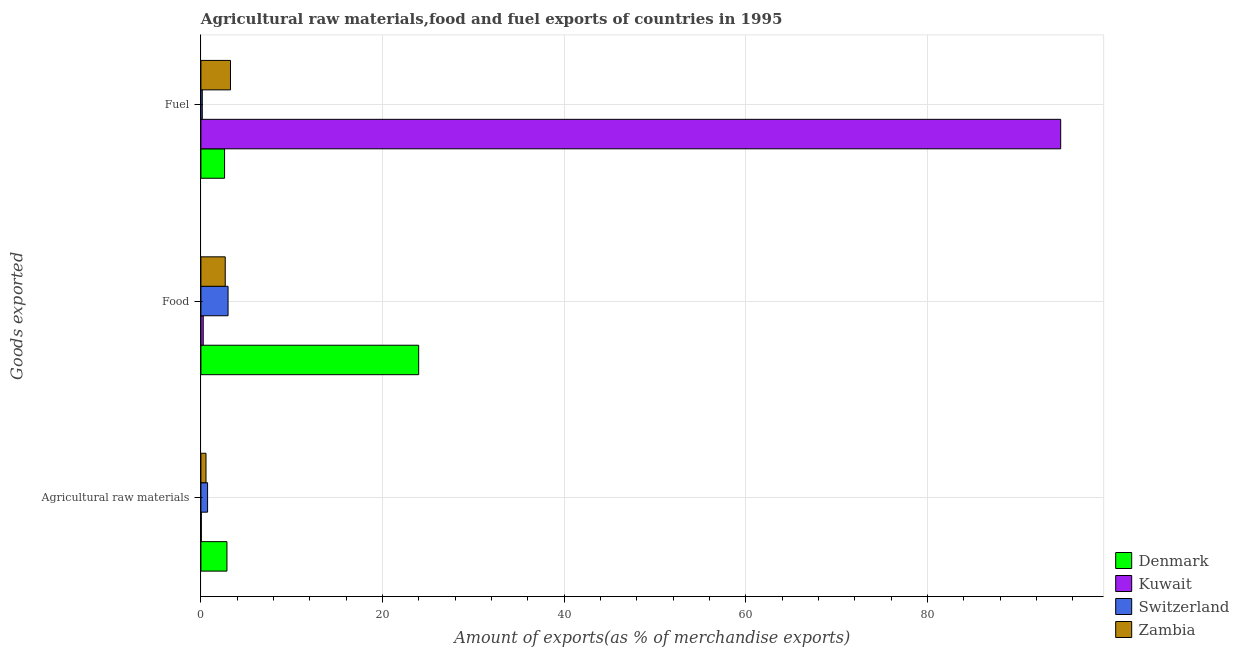How many different coloured bars are there?
Your response must be concise. 4. How many groups of bars are there?
Provide a succinct answer. 3. Are the number of bars on each tick of the Y-axis equal?
Keep it short and to the point. Yes. How many bars are there on the 3rd tick from the bottom?
Make the answer very short. 4. What is the label of the 1st group of bars from the top?
Offer a terse response. Fuel. What is the percentage of food exports in Kuwait?
Keep it short and to the point. 0.26. Across all countries, what is the maximum percentage of raw materials exports?
Make the answer very short. 2.87. Across all countries, what is the minimum percentage of raw materials exports?
Provide a succinct answer. 0.04. In which country was the percentage of fuel exports maximum?
Offer a very short reply. Kuwait. In which country was the percentage of food exports minimum?
Give a very brief answer. Kuwait. What is the total percentage of food exports in the graph?
Your answer should be very brief. 29.9. What is the difference between the percentage of fuel exports in Switzerland and that in Zambia?
Provide a succinct answer. -3.11. What is the difference between the percentage of food exports in Switzerland and the percentage of fuel exports in Kuwait?
Provide a short and direct response. -91.69. What is the average percentage of raw materials exports per country?
Ensure brevity in your answer.  1.05. What is the difference between the percentage of food exports and percentage of fuel exports in Zambia?
Your response must be concise. -0.58. What is the ratio of the percentage of fuel exports in Denmark to that in Kuwait?
Keep it short and to the point. 0.03. Is the difference between the percentage of food exports in Zambia and Kuwait greater than the difference between the percentage of fuel exports in Zambia and Kuwait?
Provide a short and direct response. Yes. What is the difference between the highest and the second highest percentage of fuel exports?
Offer a very short reply. 91.42. What is the difference between the highest and the lowest percentage of fuel exports?
Make the answer very short. 94.53. In how many countries, is the percentage of fuel exports greater than the average percentage of fuel exports taken over all countries?
Your answer should be very brief. 1. Is the sum of the percentage of fuel exports in Kuwait and Switzerland greater than the maximum percentage of food exports across all countries?
Ensure brevity in your answer.  Yes. What does the 4th bar from the top in Agricultural raw materials represents?
Your answer should be compact. Denmark. How many bars are there?
Give a very brief answer. 12. Are all the bars in the graph horizontal?
Offer a terse response. Yes. What is the difference between two consecutive major ticks on the X-axis?
Your response must be concise. 20. Does the graph contain any zero values?
Your answer should be very brief. No. Does the graph contain grids?
Offer a terse response. Yes. What is the title of the graph?
Make the answer very short. Agricultural raw materials,food and fuel exports of countries in 1995. Does "St. Lucia" appear as one of the legend labels in the graph?
Make the answer very short. No. What is the label or title of the X-axis?
Your answer should be very brief. Amount of exports(as % of merchandise exports). What is the label or title of the Y-axis?
Give a very brief answer. Goods exported. What is the Amount of exports(as % of merchandise exports) of Denmark in Agricultural raw materials?
Keep it short and to the point. 2.87. What is the Amount of exports(as % of merchandise exports) of Kuwait in Agricultural raw materials?
Give a very brief answer. 0.04. What is the Amount of exports(as % of merchandise exports) of Switzerland in Agricultural raw materials?
Your answer should be very brief. 0.73. What is the Amount of exports(as % of merchandise exports) of Zambia in Agricultural raw materials?
Give a very brief answer. 0.56. What is the Amount of exports(as % of merchandise exports) in Denmark in Food?
Offer a very short reply. 23.98. What is the Amount of exports(as % of merchandise exports) of Kuwait in Food?
Your answer should be very brief. 0.26. What is the Amount of exports(as % of merchandise exports) in Switzerland in Food?
Your response must be concise. 2.99. What is the Amount of exports(as % of merchandise exports) of Zambia in Food?
Your response must be concise. 2.68. What is the Amount of exports(as % of merchandise exports) in Denmark in Fuel?
Your response must be concise. 2.6. What is the Amount of exports(as % of merchandise exports) in Kuwait in Fuel?
Give a very brief answer. 94.68. What is the Amount of exports(as % of merchandise exports) in Switzerland in Fuel?
Offer a terse response. 0.15. What is the Amount of exports(as % of merchandise exports) in Zambia in Fuel?
Provide a short and direct response. 3.26. Across all Goods exported, what is the maximum Amount of exports(as % of merchandise exports) of Denmark?
Offer a very short reply. 23.98. Across all Goods exported, what is the maximum Amount of exports(as % of merchandise exports) of Kuwait?
Make the answer very short. 94.68. Across all Goods exported, what is the maximum Amount of exports(as % of merchandise exports) of Switzerland?
Make the answer very short. 2.99. Across all Goods exported, what is the maximum Amount of exports(as % of merchandise exports) of Zambia?
Ensure brevity in your answer.  3.26. Across all Goods exported, what is the minimum Amount of exports(as % of merchandise exports) of Denmark?
Your answer should be very brief. 2.6. Across all Goods exported, what is the minimum Amount of exports(as % of merchandise exports) in Kuwait?
Offer a very short reply. 0.04. Across all Goods exported, what is the minimum Amount of exports(as % of merchandise exports) of Switzerland?
Provide a succinct answer. 0.15. Across all Goods exported, what is the minimum Amount of exports(as % of merchandise exports) of Zambia?
Your response must be concise. 0.56. What is the total Amount of exports(as % of merchandise exports) of Denmark in the graph?
Give a very brief answer. 29.45. What is the total Amount of exports(as % of merchandise exports) in Kuwait in the graph?
Offer a terse response. 94.98. What is the total Amount of exports(as % of merchandise exports) in Switzerland in the graph?
Your answer should be compact. 3.87. What is the total Amount of exports(as % of merchandise exports) in Zambia in the graph?
Give a very brief answer. 6.5. What is the difference between the Amount of exports(as % of merchandise exports) of Denmark in Agricultural raw materials and that in Food?
Provide a succinct answer. -21.11. What is the difference between the Amount of exports(as % of merchandise exports) in Kuwait in Agricultural raw materials and that in Food?
Provide a succinct answer. -0.21. What is the difference between the Amount of exports(as % of merchandise exports) of Switzerland in Agricultural raw materials and that in Food?
Offer a very short reply. -2.25. What is the difference between the Amount of exports(as % of merchandise exports) of Zambia in Agricultural raw materials and that in Food?
Make the answer very short. -2.12. What is the difference between the Amount of exports(as % of merchandise exports) in Denmark in Agricultural raw materials and that in Fuel?
Make the answer very short. 0.26. What is the difference between the Amount of exports(as % of merchandise exports) in Kuwait in Agricultural raw materials and that in Fuel?
Make the answer very short. -94.63. What is the difference between the Amount of exports(as % of merchandise exports) of Switzerland in Agricultural raw materials and that in Fuel?
Your answer should be compact. 0.58. What is the difference between the Amount of exports(as % of merchandise exports) in Zambia in Agricultural raw materials and that in Fuel?
Keep it short and to the point. -2.7. What is the difference between the Amount of exports(as % of merchandise exports) in Denmark in Food and that in Fuel?
Provide a short and direct response. 21.37. What is the difference between the Amount of exports(as % of merchandise exports) in Kuwait in Food and that in Fuel?
Ensure brevity in your answer.  -94.42. What is the difference between the Amount of exports(as % of merchandise exports) in Switzerland in Food and that in Fuel?
Offer a very short reply. 2.84. What is the difference between the Amount of exports(as % of merchandise exports) of Zambia in Food and that in Fuel?
Keep it short and to the point. -0.58. What is the difference between the Amount of exports(as % of merchandise exports) in Denmark in Agricultural raw materials and the Amount of exports(as % of merchandise exports) in Kuwait in Food?
Give a very brief answer. 2.61. What is the difference between the Amount of exports(as % of merchandise exports) in Denmark in Agricultural raw materials and the Amount of exports(as % of merchandise exports) in Switzerland in Food?
Your answer should be very brief. -0.12. What is the difference between the Amount of exports(as % of merchandise exports) in Denmark in Agricultural raw materials and the Amount of exports(as % of merchandise exports) in Zambia in Food?
Ensure brevity in your answer.  0.19. What is the difference between the Amount of exports(as % of merchandise exports) in Kuwait in Agricultural raw materials and the Amount of exports(as % of merchandise exports) in Switzerland in Food?
Provide a short and direct response. -2.94. What is the difference between the Amount of exports(as % of merchandise exports) in Kuwait in Agricultural raw materials and the Amount of exports(as % of merchandise exports) in Zambia in Food?
Offer a terse response. -2.63. What is the difference between the Amount of exports(as % of merchandise exports) of Switzerland in Agricultural raw materials and the Amount of exports(as % of merchandise exports) of Zambia in Food?
Make the answer very short. -1.94. What is the difference between the Amount of exports(as % of merchandise exports) of Denmark in Agricultural raw materials and the Amount of exports(as % of merchandise exports) of Kuwait in Fuel?
Your response must be concise. -91.81. What is the difference between the Amount of exports(as % of merchandise exports) of Denmark in Agricultural raw materials and the Amount of exports(as % of merchandise exports) of Switzerland in Fuel?
Provide a short and direct response. 2.72. What is the difference between the Amount of exports(as % of merchandise exports) of Denmark in Agricultural raw materials and the Amount of exports(as % of merchandise exports) of Zambia in Fuel?
Your answer should be very brief. -0.39. What is the difference between the Amount of exports(as % of merchandise exports) in Kuwait in Agricultural raw materials and the Amount of exports(as % of merchandise exports) in Switzerland in Fuel?
Offer a terse response. -0.11. What is the difference between the Amount of exports(as % of merchandise exports) of Kuwait in Agricultural raw materials and the Amount of exports(as % of merchandise exports) of Zambia in Fuel?
Make the answer very short. -3.21. What is the difference between the Amount of exports(as % of merchandise exports) of Switzerland in Agricultural raw materials and the Amount of exports(as % of merchandise exports) of Zambia in Fuel?
Provide a short and direct response. -2.52. What is the difference between the Amount of exports(as % of merchandise exports) in Denmark in Food and the Amount of exports(as % of merchandise exports) in Kuwait in Fuel?
Your answer should be compact. -70.7. What is the difference between the Amount of exports(as % of merchandise exports) of Denmark in Food and the Amount of exports(as % of merchandise exports) of Switzerland in Fuel?
Provide a succinct answer. 23.83. What is the difference between the Amount of exports(as % of merchandise exports) in Denmark in Food and the Amount of exports(as % of merchandise exports) in Zambia in Fuel?
Ensure brevity in your answer.  20.72. What is the difference between the Amount of exports(as % of merchandise exports) in Kuwait in Food and the Amount of exports(as % of merchandise exports) in Switzerland in Fuel?
Give a very brief answer. 0.1. What is the difference between the Amount of exports(as % of merchandise exports) in Kuwait in Food and the Amount of exports(as % of merchandise exports) in Zambia in Fuel?
Offer a very short reply. -3. What is the difference between the Amount of exports(as % of merchandise exports) of Switzerland in Food and the Amount of exports(as % of merchandise exports) of Zambia in Fuel?
Offer a terse response. -0.27. What is the average Amount of exports(as % of merchandise exports) of Denmark per Goods exported?
Provide a succinct answer. 9.82. What is the average Amount of exports(as % of merchandise exports) of Kuwait per Goods exported?
Give a very brief answer. 31.66. What is the average Amount of exports(as % of merchandise exports) in Switzerland per Goods exported?
Your response must be concise. 1.29. What is the average Amount of exports(as % of merchandise exports) of Zambia per Goods exported?
Keep it short and to the point. 2.17. What is the difference between the Amount of exports(as % of merchandise exports) of Denmark and Amount of exports(as % of merchandise exports) of Kuwait in Agricultural raw materials?
Provide a succinct answer. 2.82. What is the difference between the Amount of exports(as % of merchandise exports) in Denmark and Amount of exports(as % of merchandise exports) in Switzerland in Agricultural raw materials?
Ensure brevity in your answer.  2.13. What is the difference between the Amount of exports(as % of merchandise exports) of Denmark and Amount of exports(as % of merchandise exports) of Zambia in Agricultural raw materials?
Your response must be concise. 2.31. What is the difference between the Amount of exports(as % of merchandise exports) of Kuwait and Amount of exports(as % of merchandise exports) of Switzerland in Agricultural raw materials?
Your answer should be very brief. -0.69. What is the difference between the Amount of exports(as % of merchandise exports) of Kuwait and Amount of exports(as % of merchandise exports) of Zambia in Agricultural raw materials?
Give a very brief answer. -0.52. What is the difference between the Amount of exports(as % of merchandise exports) of Switzerland and Amount of exports(as % of merchandise exports) of Zambia in Agricultural raw materials?
Your answer should be very brief. 0.17. What is the difference between the Amount of exports(as % of merchandise exports) of Denmark and Amount of exports(as % of merchandise exports) of Kuwait in Food?
Your answer should be compact. 23.72. What is the difference between the Amount of exports(as % of merchandise exports) of Denmark and Amount of exports(as % of merchandise exports) of Switzerland in Food?
Your answer should be very brief. 20.99. What is the difference between the Amount of exports(as % of merchandise exports) of Denmark and Amount of exports(as % of merchandise exports) of Zambia in Food?
Your answer should be very brief. 21.3. What is the difference between the Amount of exports(as % of merchandise exports) in Kuwait and Amount of exports(as % of merchandise exports) in Switzerland in Food?
Give a very brief answer. -2.73. What is the difference between the Amount of exports(as % of merchandise exports) in Kuwait and Amount of exports(as % of merchandise exports) in Zambia in Food?
Offer a very short reply. -2.42. What is the difference between the Amount of exports(as % of merchandise exports) of Switzerland and Amount of exports(as % of merchandise exports) of Zambia in Food?
Your answer should be very brief. 0.31. What is the difference between the Amount of exports(as % of merchandise exports) of Denmark and Amount of exports(as % of merchandise exports) of Kuwait in Fuel?
Your response must be concise. -92.07. What is the difference between the Amount of exports(as % of merchandise exports) of Denmark and Amount of exports(as % of merchandise exports) of Switzerland in Fuel?
Ensure brevity in your answer.  2.45. What is the difference between the Amount of exports(as % of merchandise exports) of Denmark and Amount of exports(as % of merchandise exports) of Zambia in Fuel?
Make the answer very short. -0.65. What is the difference between the Amount of exports(as % of merchandise exports) of Kuwait and Amount of exports(as % of merchandise exports) of Switzerland in Fuel?
Make the answer very short. 94.53. What is the difference between the Amount of exports(as % of merchandise exports) of Kuwait and Amount of exports(as % of merchandise exports) of Zambia in Fuel?
Offer a very short reply. 91.42. What is the difference between the Amount of exports(as % of merchandise exports) of Switzerland and Amount of exports(as % of merchandise exports) of Zambia in Fuel?
Give a very brief answer. -3.11. What is the ratio of the Amount of exports(as % of merchandise exports) in Denmark in Agricultural raw materials to that in Food?
Give a very brief answer. 0.12. What is the ratio of the Amount of exports(as % of merchandise exports) of Kuwait in Agricultural raw materials to that in Food?
Your answer should be very brief. 0.17. What is the ratio of the Amount of exports(as % of merchandise exports) in Switzerland in Agricultural raw materials to that in Food?
Offer a very short reply. 0.25. What is the ratio of the Amount of exports(as % of merchandise exports) of Zambia in Agricultural raw materials to that in Food?
Your response must be concise. 0.21. What is the ratio of the Amount of exports(as % of merchandise exports) in Denmark in Agricultural raw materials to that in Fuel?
Your answer should be compact. 1.1. What is the ratio of the Amount of exports(as % of merchandise exports) of Kuwait in Agricultural raw materials to that in Fuel?
Your response must be concise. 0. What is the ratio of the Amount of exports(as % of merchandise exports) in Switzerland in Agricultural raw materials to that in Fuel?
Provide a short and direct response. 4.85. What is the ratio of the Amount of exports(as % of merchandise exports) of Zambia in Agricultural raw materials to that in Fuel?
Your answer should be compact. 0.17. What is the ratio of the Amount of exports(as % of merchandise exports) of Denmark in Food to that in Fuel?
Your answer should be compact. 9.21. What is the ratio of the Amount of exports(as % of merchandise exports) of Kuwait in Food to that in Fuel?
Make the answer very short. 0. What is the ratio of the Amount of exports(as % of merchandise exports) of Switzerland in Food to that in Fuel?
Your response must be concise. 19.77. What is the ratio of the Amount of exports(as % of merchandise exports) in Zambia in Food to that in Fuel?
Ensure brevity in your answer.  0.82. What is the difference between the highest and the second highest Amount of exports(as % of merchandise exports) of Denmark?
Your answer should be very brief. 21.11. What is the difference between the highest and the second highest Amount of exports(as % of merchandise exports) in Kuwait?
Your answer should be very brief. 94.42. What is the difference between the highest and the second highest Amount of exports(as % of merchandise exports) of Switzerland?
Offer a terse response. 2.25. What is the difference between the highest and the second highest Amount of exports(as % of merchandise exports) of Zambia?
Offer a terse response. 0.58. What is the difference between the highest and the lowest Amount of exports(as % of merchandise exports) of Denmark?
Provide a short and direct response. 21.37. What is the difference between the highest and the lowest Amount of exports(as % of merchandise exports) of Kuwait?
Provide a short and direct response. 94.63. What is the difference between the highest and the lowest Amount of exports(as % of merchandise exports) in Switzerland?
Ensure brevity in your answer.  2.84. What is the difference between the highest and the lowest Amount of exports(as % of merchandise exports) in Zambia?
Your answer should be compact. 2.7. 